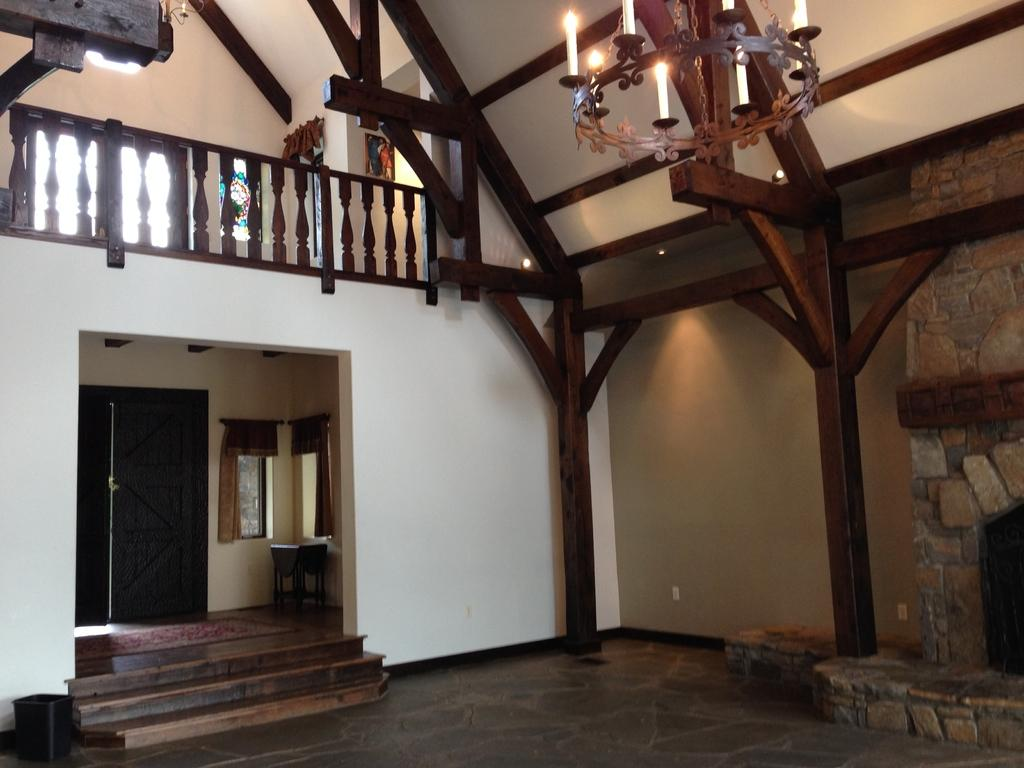What type of location is depicted in the image? The image shows an inside view of a house. What lighting fixture can be seen in the image? There is a chandelier in the image. What architectural feature is visible in the image? A staircase is visible in the image. What allows natural light to enter the house in the image? There is a window in the image. What material is used for the poles in the image? Wooden poles are present in the image. What type of pancake is being served on the wooden poles in the image? There is no pancake present in the image; the wooden poles are not serving any food. 